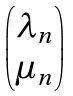Convert formula to latex. <formula><loc_0><loc_0><loc_500><loc_500>\begin{pmatrix} \lambda _ { n } \\ \mu _ { n } \end{pmatrix}</formula> 